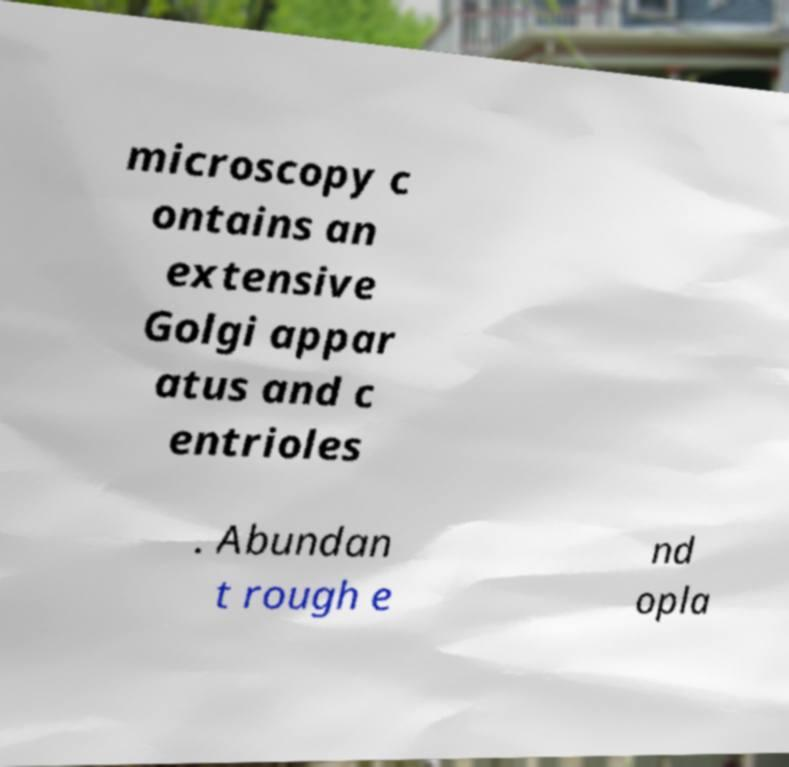Could you extract and type out the text from this image? microscopy c ontains an extensive Golgi appar atus and c entrioles . Abundan t rough e nd opla 